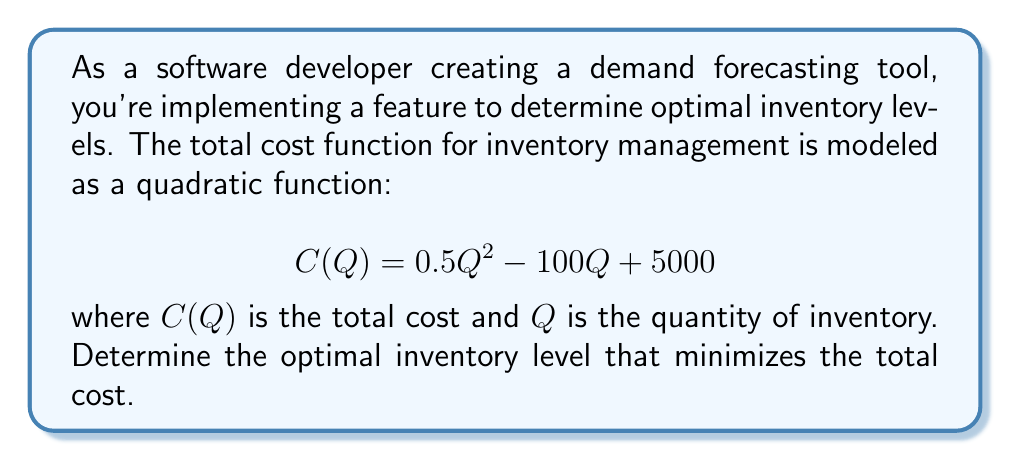Solve this math problem. To find the optimal inventory level that minimizes the total cost, we need to find the minimum point of the quadratic function. This can be done by following these steps:

1. The quadratic function is in the form $C(Q) = aQ^2 + bQ + c$, where:
   $a = 0.5$
   $b = -100$
   $c = 5000$

2. For a quadratic function, the minimum (or maximum) point occurs at the vertex. The Q-coordinate of the vertex can be found using the formula:

   $$Q = -\frac{b}{2a}$$

3. Substituting the values:

   $$Q = -\frac{-100}{2(0.5)} = \frac{100}{1} = 100$$

4. To verify this is a minimum (not a maximum), we can check that $a > 0$, which is true in this case $(0.5 > 0)$.

5. Therefore, the optimal inventory level that minimizes the total cost is 100 units.

We can also interpret this result in the context of the problem:
- When the inventory level is below 100 units, increasing inventory will decrease costs more than the storage costs increase.
- When the inventory level is above 100 units, the increase in storage costs outweighs the benefits of having additional inventory.

This optimal point balances the trade-off between having too little inventory (which may lead to stockouts and lost sales) and having too much inventory (which increases storage costs).
Answer: The optimal inventory level that minimizes the total cost is 100 units. 